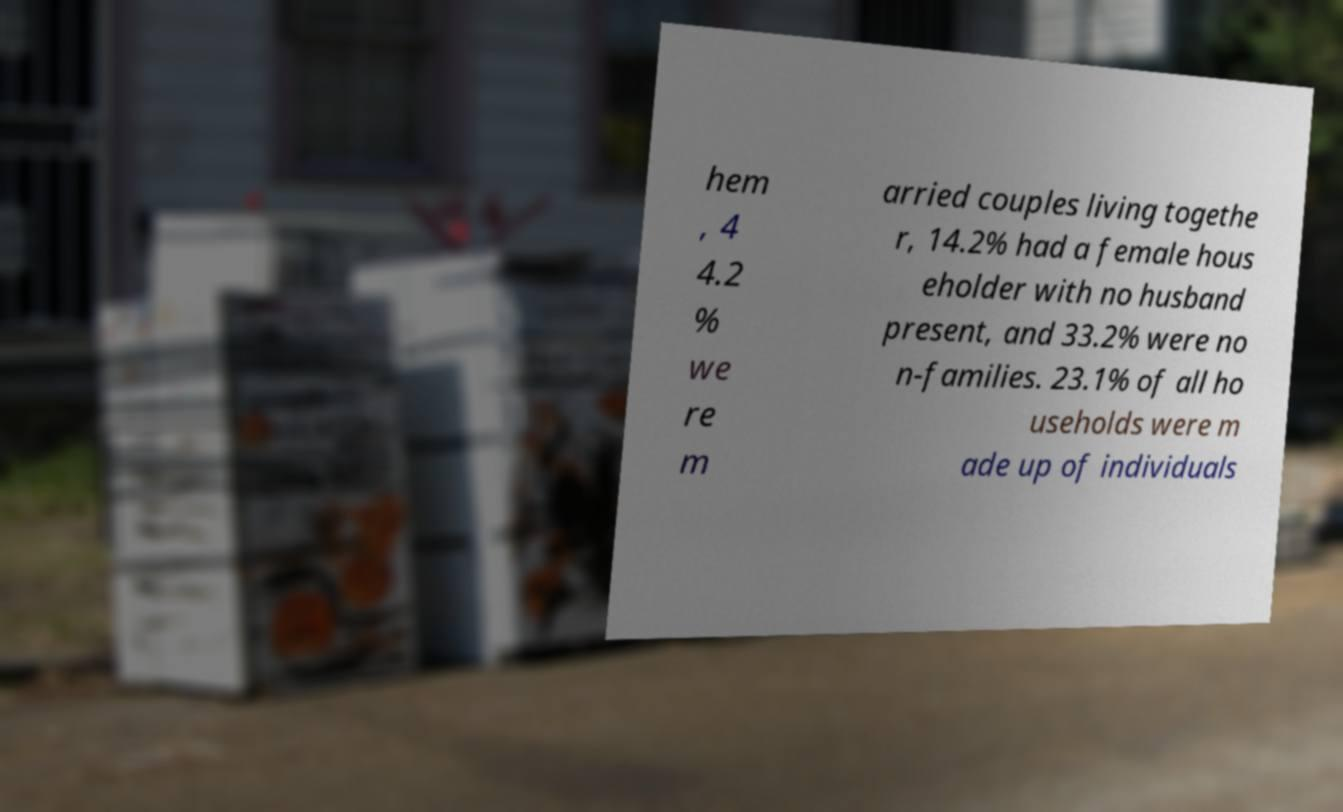Can you accurately transcribe the text from the provided image for me? hem , 4 4.2 % we re m arried couples living togethe r, 14.2% had a female hous eholder with no husband present, and 33.2% were no n-families. 23.1% of all ho useholds were m ade up of individuals 